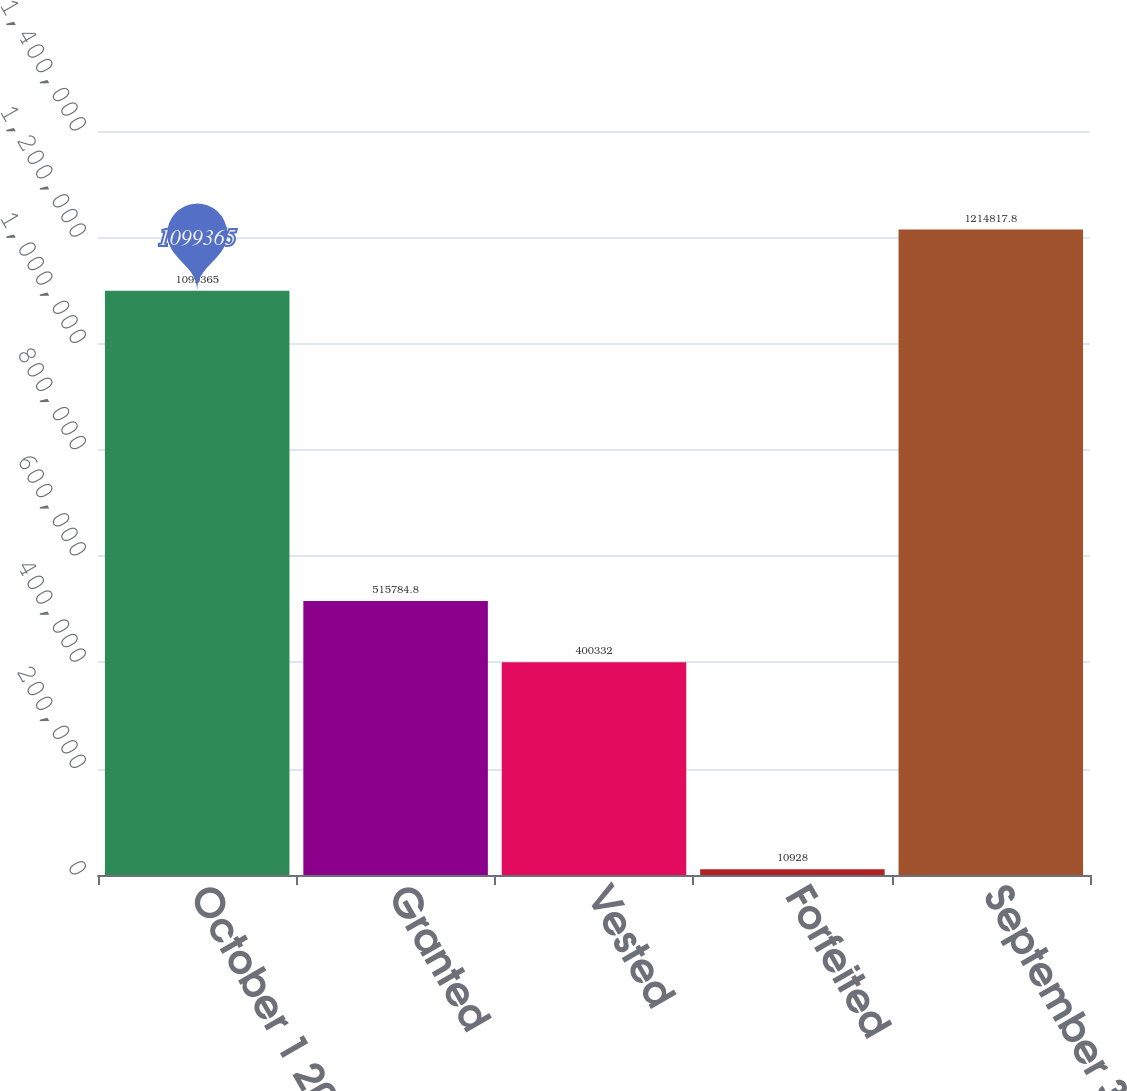Convert chart to OTSL. <chart><loc_0><loc_0><loc_500><loc_500><bar_chart><fcel>October 1 2008<fcel>Granted<fcel>Vested<fcel>Forfeited<fcel>September 30 2009<nl><fcel>1.09936e+06<fcel>515785<fcel>400332<fcel>10928<fcel>1.21482e+06<nl></chart> 